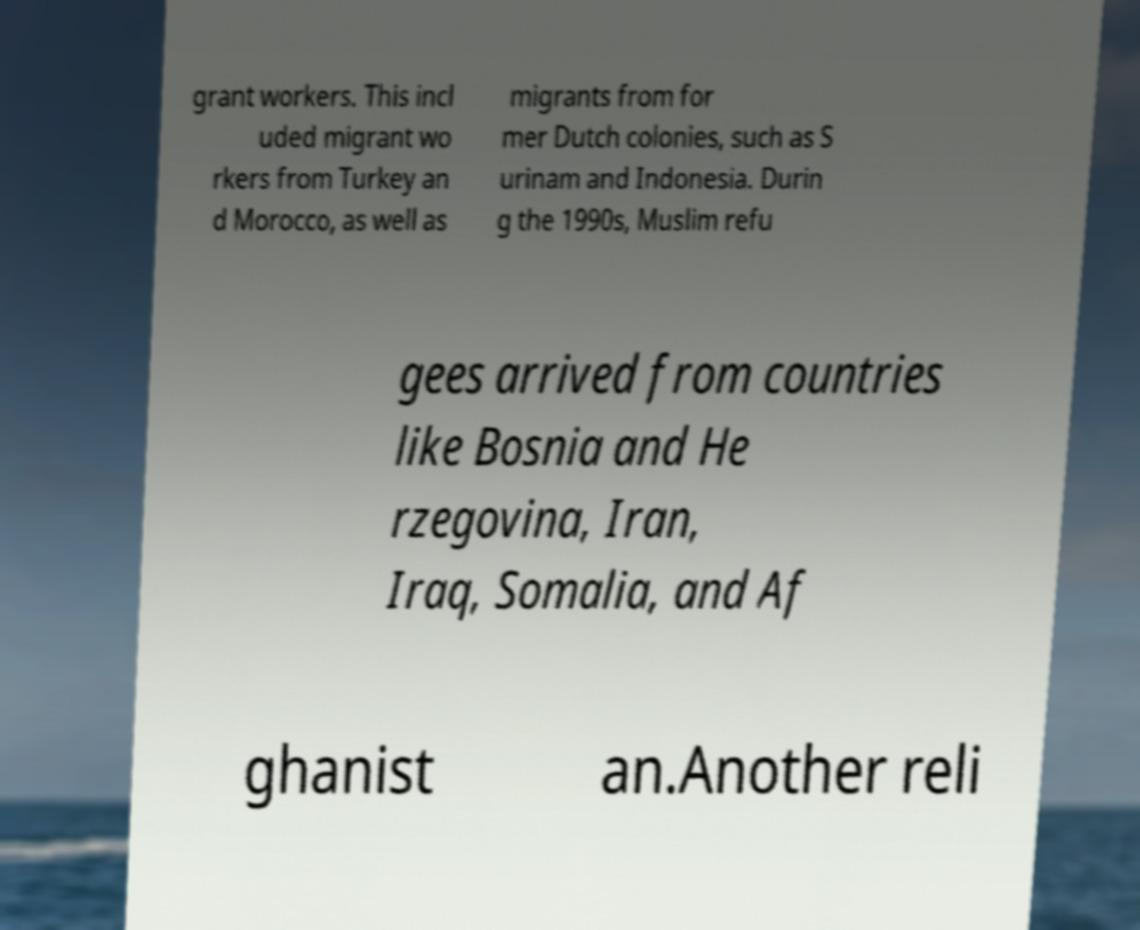I need the written content from this picture converted into text. Can you do that? grant workers. This incl uded migrant wo rkers from Turkey an d Morocco, as well as migrants from for mer Dutch colonies, such as S urinam and Indonesia. Durin g the 1990s, Muslim refu gees arrived from countries like Bosnia and He rzegovina, Iran, Iraq, Somalia, and Af ghanist an.Another reli 